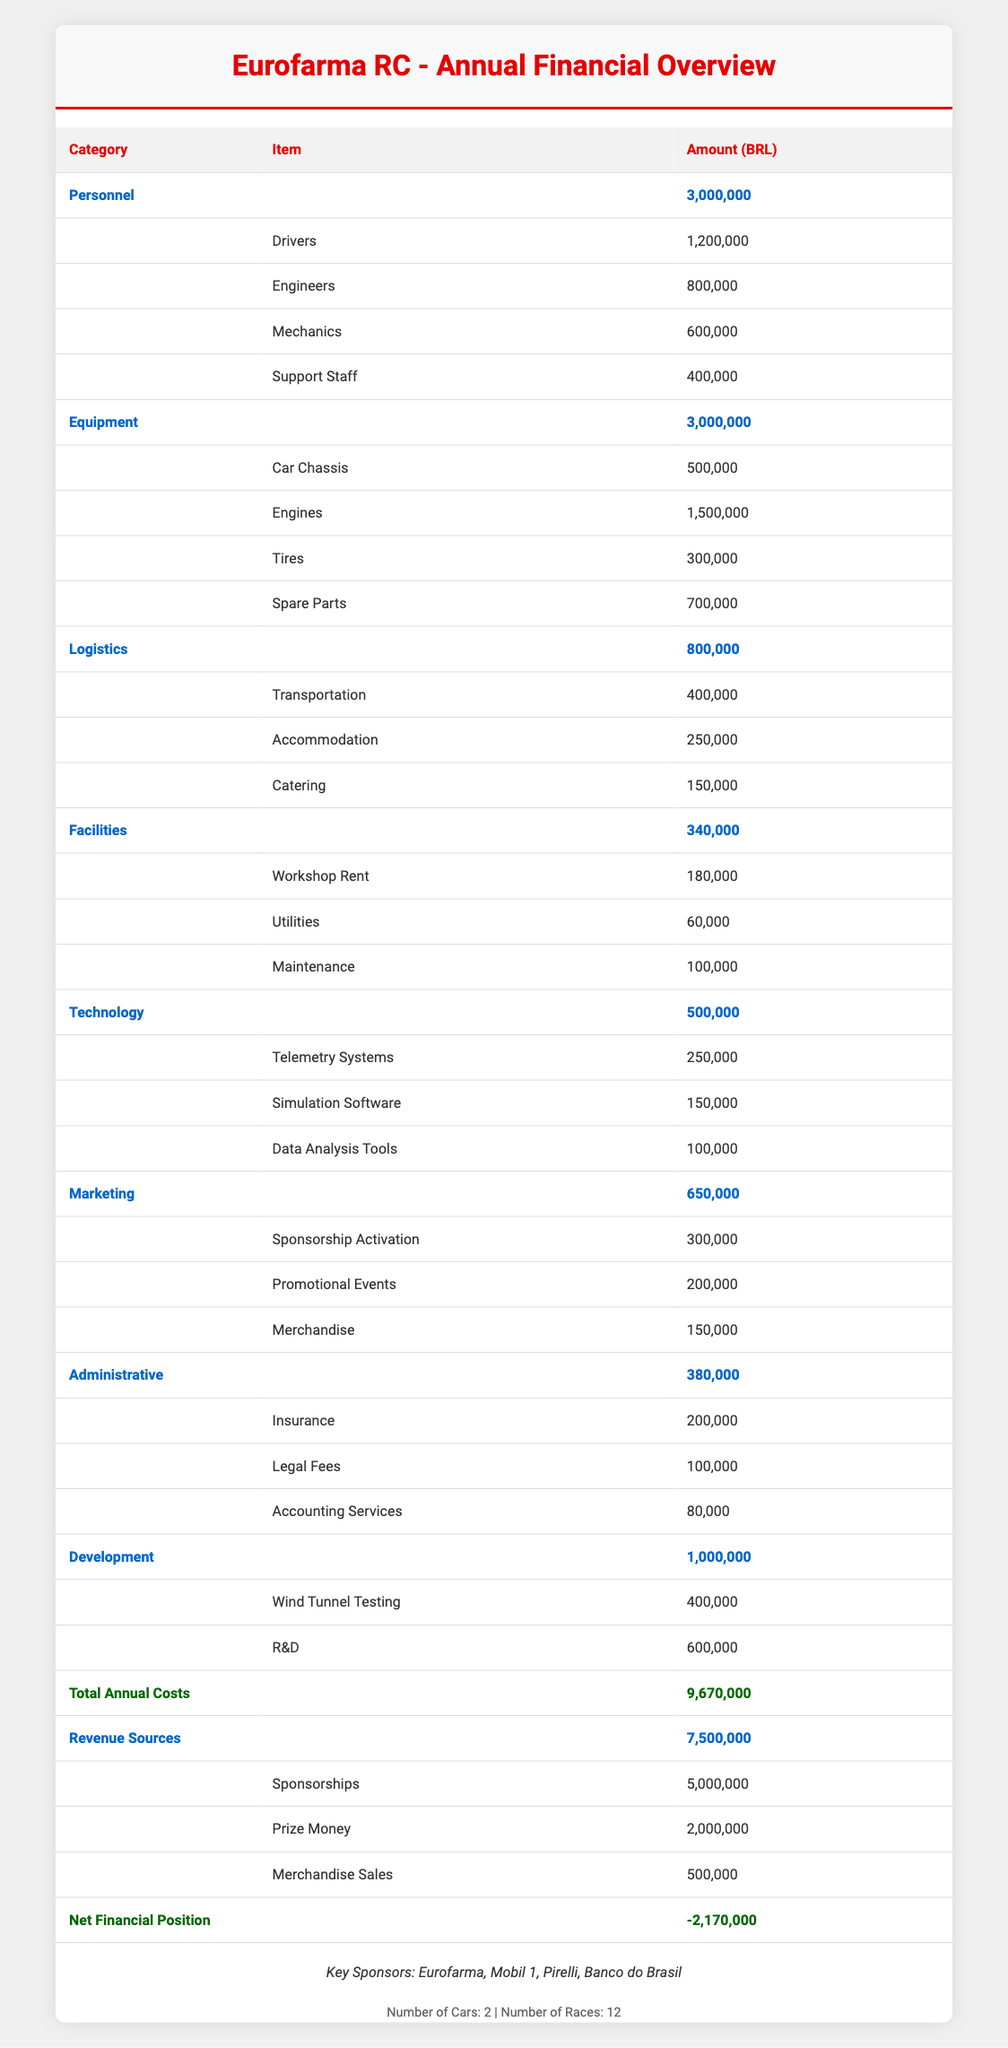What are the total annual costs for the Eurofarma RC racing team? The total annual costs are presented in the last row of the table under "Total Annual Costs," which indicates 9,670,000 BRL.
Answer: 9,670,000 BRL How much is allocated for personnel expenses? The table shows that personnel costs total 3,000,000 BRL (calculated from the sum of drivers, engineers, mechanics, and support staff).
Answer: 3,000,000 BRL Is the revenue from sponsorships greater than the total costs? The sponsorship revenue amounts to 5,000,000 BRL, which is less than the total costs of 9,670,000 BRL, indicating that sponsorships alone do not cover costs.
Answer: No What is the total cost of logistics? To find the total logistics cost, we sum the individual components: transportation (400,000 BRL), accommodation (250,000 BRL), and catering (150,000 BRL). This totals 800,000 BRL.
Answer: 800,000 BRL What is the net financial position of the team? The net financial position is found at the end of the revenue section, calculated as total revenue (7,500,000 BRL) minus total costs (9,670,000 BRL), resulting in -2,170,000 BRL.
Answer: -2,170,000 BRL How much more is spent on personnel compared to technology? Personnel costs are 3,000,000 BRL, while technology costs are 500,000 BRL. The difference is 3,000,000 BRL - 500,000 BRL = 2,500,000 BRL.
Answer: 2,500,000 BRL Does the team have more expenses in equipment than in development? Equipment costs total 3,000,000 BRL and development costs total 1,000,000 BRL, confirming that equipment expenses are greater.
Answer: Yes What percentage of the total costs goes to marketing? Marketing costs are 650,000 BRL out of total costs of 9,670,000 BRL. The percentage is (650,000 / 9,670,000) * 100 ≈ 6.72%.
Answer: Approximately 6.72% What is the total revenue, and how does it compare to the total annual costs? Total revenue sums to 7,500,000 BRL (from sponsorships, prize money, merchandise) versus total costs of 9,670,000 BRL, indicating a deficit.
Answer: 7,500,000 BRL How much does the team spend on marketing events specifically? The table lists the cost for promotional events as 200,000 BRL, which is the specific entry for marketing events.
Answer: 200,000 BRL 